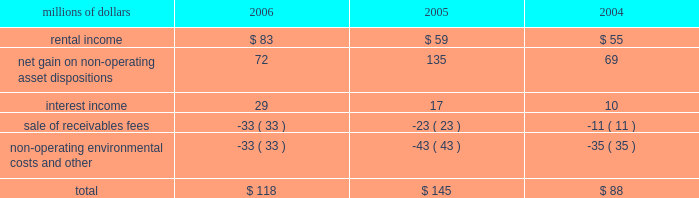The environmental liability includes costs for remediation and restoration of sites , as well as for ongoing monitoring costs , but excludes any anticipated recoveries from third parties .
Cost estimates are based on information available for each site , financial viability of other potentially responsible parties , and existing technology , laws , and regulations .
We believe that we have adequately accrued for our ultimate share of costs at sites subject to joint and several liability .
However , the ultimate liability for remediation is difficult to determine because of the number of potentially responsible parties involved , site-specific cost sharing arrangements with other potentially responsible parties , the degree of contamination by various wastes , the scarcity and quality of volumetric data related to many of the sites , and the speculative nature of remediation costs .
Estimates may also vary due to changes in federal , state , and local laws governing environmental remediation .
We do not expect current obligations to have a material adverse effect on our results of operations or financial condition .
Guarantees 2013 at december 31 , 2006 , we were contingently liable for $ 464 million in guarantees .
We have recorded a liability of $ 6 million for the fair value of these obligations as of december 31 , 2006 .
We entered into these contingent guarantees in the normal course of business , and they include guaranteed obligations related to our headquarters building , equipment financings , and affiliated operations .
The final guarantee expires in 2022 .
We are not aware of any existing event of default that would require us to satisfy these guarantees .
We do not expect that these guarantees will have a material adverse effect on our consolidated financial condition , results of operations , or liquidity .
Indemnities 2013 our maximum potential exposure under indemnification arrangements , including certain tax indemnifications , can range from a specified dollar amount to an unlimited amount , depending on the nature of the transactions and the agreements .
Due to uncertainty as to whether claims will be made or how they will be resolved , we cannot reasonably determine the probability of an adverse claim or reasonably estimate any adverse liability or the total maximum exposure under these indemnification arrangements .
We do not have any reason to believe that we will be required to make any material payments under these indemnity provisions .
Income taxes 2013 as previously reported in our form 10-q for the quarter ended september 30 , 2005 , the irs has completed its examinations and issued notices of deficiency for tax years 1995 through 2002 .
Among their proposed adjustments is the disallowance of tax deductions claimed in connection with certain donations of property .
In the fourth quarter of 2005 , the irs national office issued a technical advice memorandum which left unresolved whether the deductions were proper , pending further factual development .
We continue to dispute the donation issue , as well as many of the other proposed adjustments , and will contest the associated tax deficiencies through the irs appeals process , and , if necessary , litigation .
In addition , the irs is examining the corporation 2019s federal income tax returns for tax years 2003 and 2004 and should complete their exam in 2007 .
We do not expect that the ultimate resolution of these examinations will have a material adverse effect on our consolidated financial statements .
11 .
Other income other income included the following for the years ended december 31 : millions of dollars 2006 2005 2004 .

In 2006 what was the total other income less fees? 
Computations: ((118 - -33) - -33)
Answer: 184.0. 